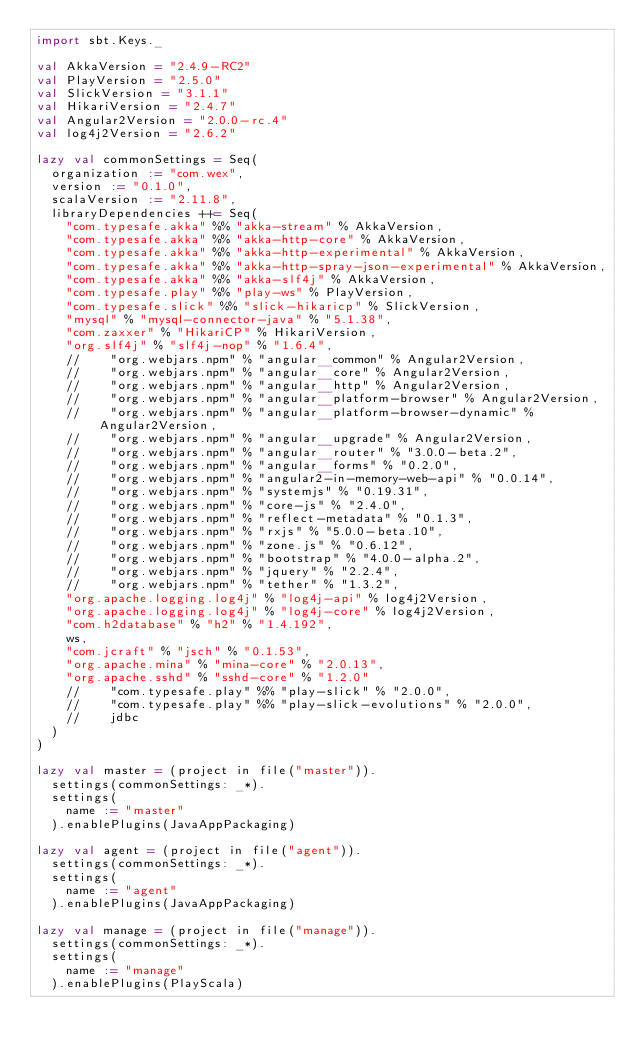Convert code to text. <code><loc_0><loc_0><loc_500><loc_500><_Scala_>import sbt.Keys._

val AkkaVersion = "2.4.9-RC2"
val PlayVersion = "2.5.0"
val SlickVersion = "3.1.1"
val HikariVersion = "2.4.7"
val Angular2Version = "2.0.0-rc.4"
val log4j2Version = "2.6.2"

lazy val commonSettings = Seq(
  organization := "com.wex",
  version := "0.1.0",
  scalaVersion := "2.11.8",
  libraryDependencies ++= Seq(
    "com.typesafe.akka" %% "akka-stream" % AkkaVersion,
    "com.typesafe.akka" %% "akka-http-core" % AkkaVersion,
    "com.typesafe.akka" %% "akka-http-experimental" % AkkaVersion,
    "com.typesafe.akka" %% "akka-http-spray-json-experimental" % AkkaVersion,
    "com.typesafe.akka" %% "akka-slf4j" % AkkaVersion,
    "com.typesafe.play" %% "play-ws" % PlayVersion,
    "com.typesafe.slick" %% "slick-hikaricp" % SlickVersion,
    "mysql" % "mysql-connector-java" % "5.1.38",
    "com.zaxxer" % "HikariCP" % HikariVersion,
    "org.slf4j" % "slf4j-nop" % "1.6.4",
    //    "org.webjars.npm" % "angular__common" % Angular2Version,
    //    "org.webjars.npm" % "angular__core" % Angular2Version,
    //    "org.webjars.npm" % "angular__http" % Angular2Version,
    //    "org.webjars.npm" % "angular__platform-browser" % Angular2Version,
    //    "org.webjars.npm" % "angular__platform-browser-dynamic" % Angular2Version,
    //    "org.webjars.npm" % "angular__upgrade" % Angular2Version,
    //    "org.webjars.npm" % "angular__router" % "3.0.0-beta.2",
    //    "org.webjars.npm" % "angular__forms" % "0.2.0",
    //    "org.webjars.npm" % "angular2-in-memory-web-api" % "0.0.14",
    //    "org.webjars.npm" % "systemjs" % "0.19.31",
    //    "org.webjars.npm" % "core-js" % "2.4.0",
    //    "org.webjars.npm" % "reflect-metadata" % "0.1.3",
    //    "org.webjars.npm" % "rxjs" % "5.0.0-beta.10",
    //    "org.webjars.npm" % "zone.js" % "0.6.12",
    //    "org.webjars.npm" % "bootstrap" % "4.0.0-alpha.2",
    //    "org.webjars.npm" % "jquery" % "2.2.4",
    //    "org.webjars.npm" % "tether" % "1.3.2",
    "org.apache.logging.log4j" % "log4j-api" % log4j2Version,
    "org.apache.logging.log4j" % "log4j-core" % log4j2Version,
    "com.h2database" % "h2" % "1.4.192",
    ws,
    "com.jcraft" % "jsch" % "0.1.53",
    "org.apache.mina" % "mina-core" % "2.0.13",
    "org.apache.sshd" % "sshd-core" % "1.2.0"
    //    "com.typesafe.play" %% "play-slick" % "2.0.0",
    //    "com.typesafe.play" %% "play-slick-evolutions" % "2.0.0",
    //    jdbc
  )
)

lazy val master = (project in file("master")).
  settings(commonSettings: _*).
  settings(
    name := "master"
  ).enablePlugins(JavaAppPackaging)

lazy val agent = (project in file("agent")).
  settings(commonSettings: _*).
  settings(
    name := "agent"
  ).enablePlugins(JavaAppPackaging)

lazy val manage = (project in file("manage")).
  settings(commonSettings: _*).
  settings(
    name := "manage"
  ).enablePlugins(PlayScala)</code> 